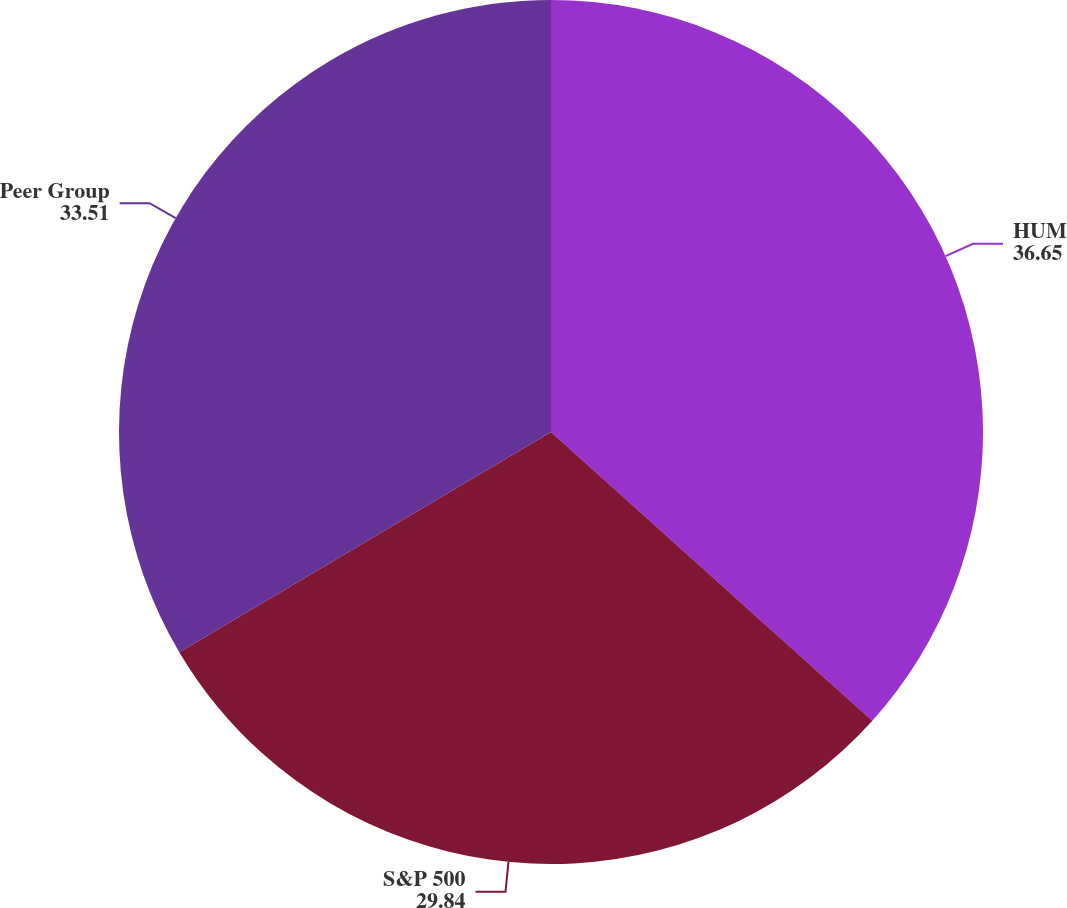Convert chart to OTSL. <chart><loc_0><loc_0><loc_500><loc_500><pie_chart><fcel>HUM<fcel>S&P 500<fcel>Peer Group<nl><fcel>36.65%<fcel>29.84%<fcel>33.51%<nl></chart> 